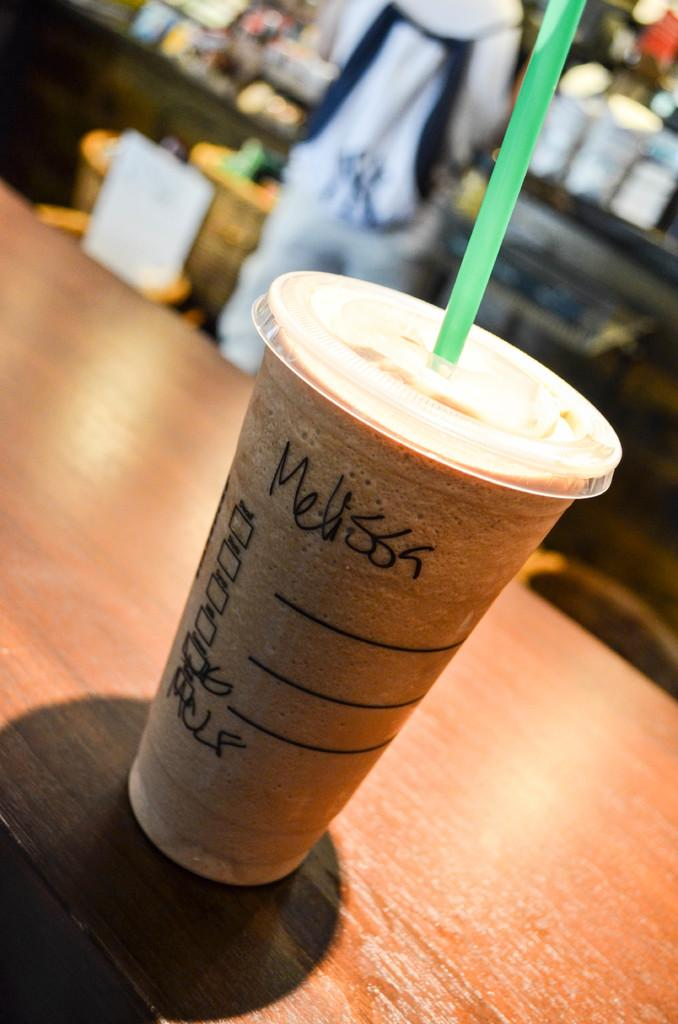What is on the table in the image? There is a cup on the table. What is inside the cup? There is a drink in the cup. Can you describe the person visible in the background? Unfortunately, the facts provided do not give any details about the person in the background. What else can be seen in the background of the image? There are other unspecified elements in the background. What type of rat can be seen climbing the edge of the cup in the image? There is no rat present in the image, and therefore no such activity can be observed. 